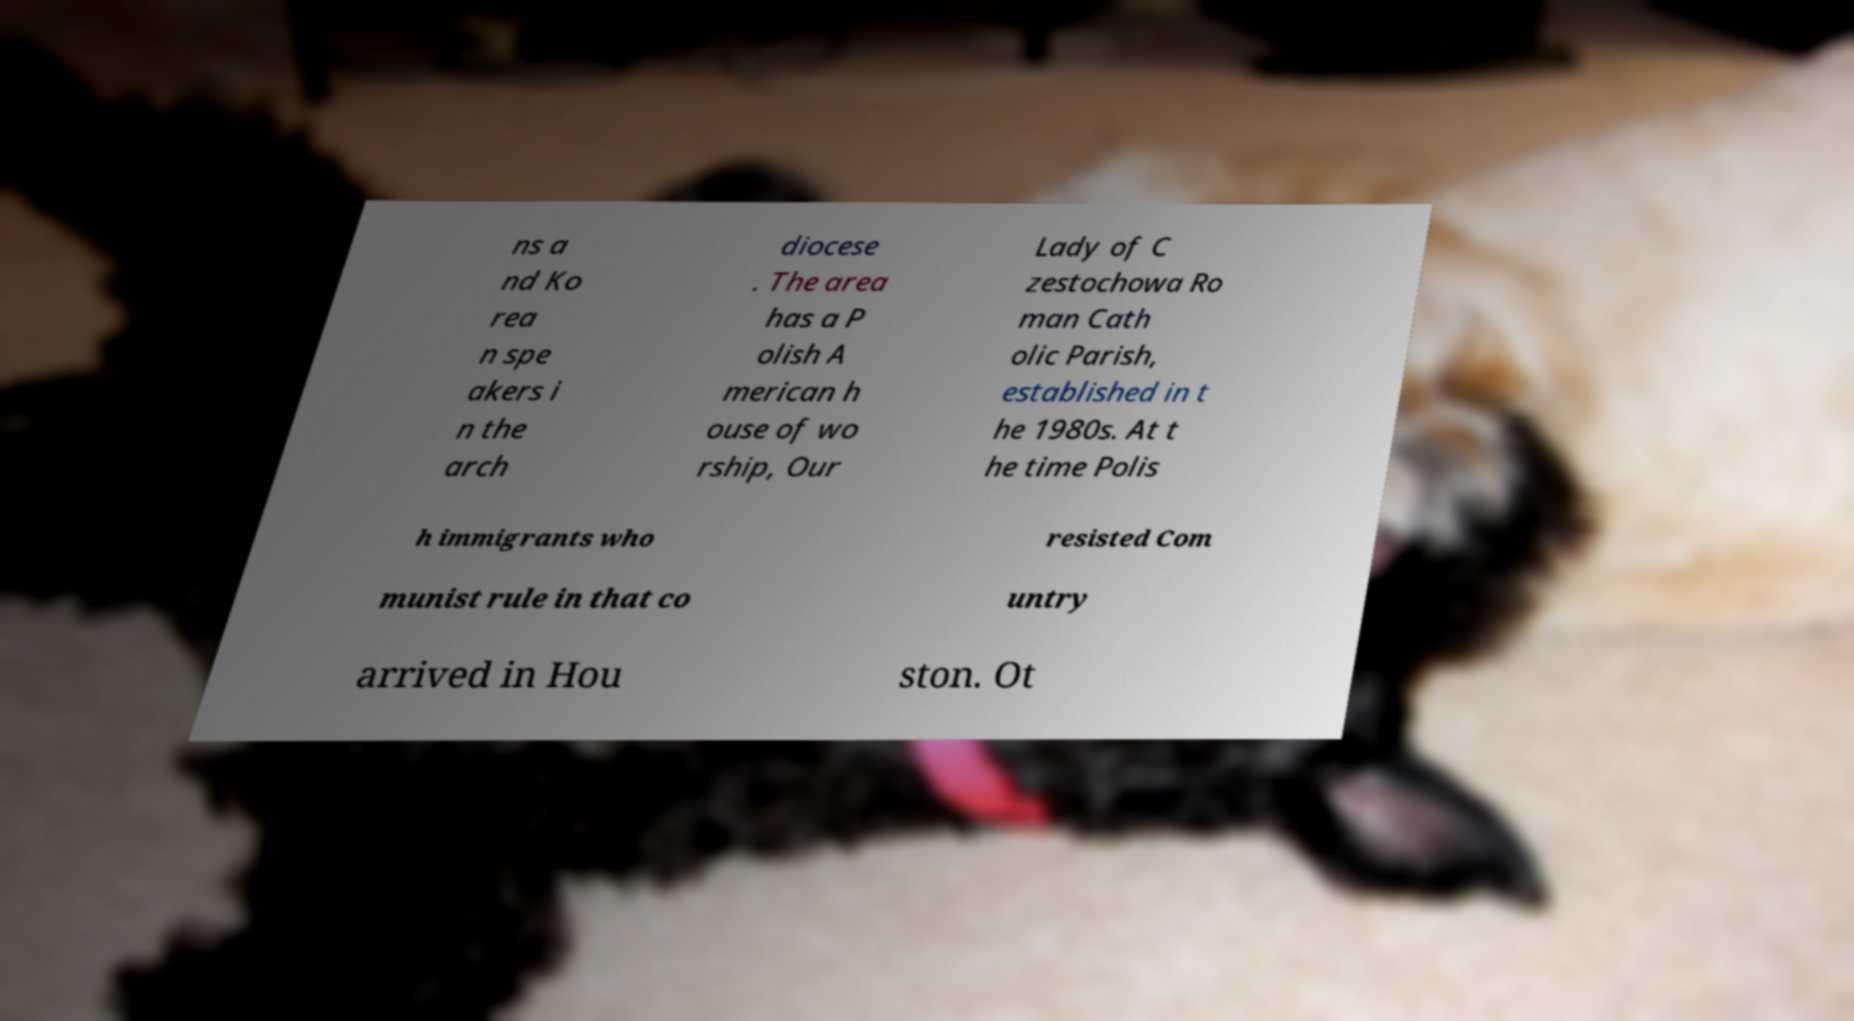Could you extract and type out the text from this image? ns a nd Ko rea n spe akers i n the arch diocese . The area has a P olish A merican h ouse of wo rship, Our Lady of C zestochowa Ro man Cath olic Parish, established in t he 1980s. At t he time Polis h immigrants who resisted Com munist rule in that co untry arrived in Hou ston. Ot 